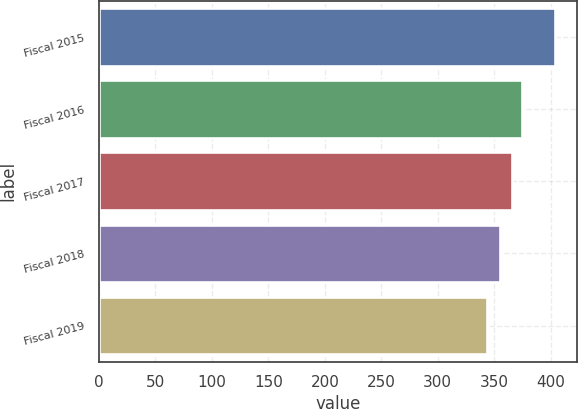Convert chart to OTSL. <chart><loc_0><loc_0><loc_500><loc_500><bar_chart><fcel>Fiscal 2015<fcel>Fiscal 2016<fcel>Fiscal 2017<fcel>Fiscal 2018<fcel>Fiscal 2019<nl><fcel>403.3<fcel>374.5<fcel>365.4<fcel>354.9<fcel>343.1<nl></chart> 